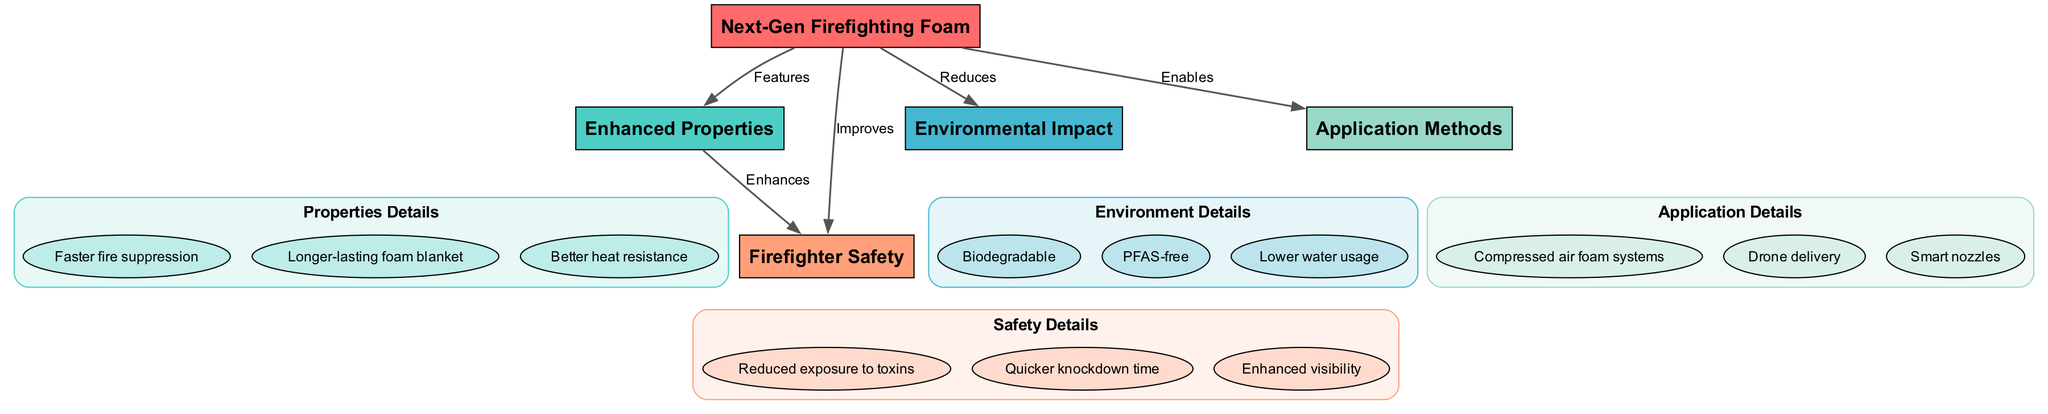What is the main subject of the diagram? The diagram is centered around "Next-Gen Firefighting Foam," which serves as the primary node that connects to various other topics surrounding its properties, environmental impact, safety, and application methods.
Answer: Next-Gen Firefighting Foam How many enhancements are listed under "Enhanced Properties"? The "Enhanced Properties" sub-node includes three enhancements: Faster fire suppression, Longer-lasting foam blanket, and Better heat resistance, indicating there are three enhancements.
Answer: 3 What impact does the next-gen foam have on environmental factors? The diagram indicates that the next-gen foam "Reduces" environmental impact, and specifically lists features such as being Biodegradable, PFAS-free, and Lower water usage, highlighting a focus on environmental benefits.
Answer: Reduces What relationship exists between "Enhanced Properties" and "Firefighter Safety"? According to the diagram, "Enhanced Properties" leads to "Firefighter Safety" where it shows that the enhancements "Enhances" safety, implying a positive influence of foam properties on safety measures for firefighters.
Answer: Enhances Which application method allows the next-gen foam to be delivered remotely? The diagram lists "Drone delivery" as one of the application methods under "Application Methods," indicating a modern technique for remote delivery of the firefighting foam.
Answer: Drone delivery How does next-gen foam improve firefighter safety? The diagram states that the firefighting foam "Improves" firefighter safety and specifies three aspects: Reduced exposure to toxins, Quicker knockdown time, and Enhanced visibility, showing how it safeguards firefighters.
Answer: Improves What are the three topics connected to the "Next-Gen Firefighting Foam"? The four primary topics branched from "Next-Gen Firefighting Foam" are "Enhanced Properties," "Environmental Impact," "Firefighter Safety," and "Application Methods," revealing the multifaceted benefits of the foam.
Answer: 4 Which enhancement focuses on the duration of effectiveness? The sub-node "Longer-lasting foam blanket" under "Enhanced Properties" specifically addresses the duration of effectiveness, indicating a feature that ensures longer operational capacity during firefighting.
Answer: Longer-lasting foam blanket What do the safety enhancements seek to mitigate? The enhancements under "Firefighter Safety" primarily seek to mitigate the exposure to toxins and provide a quicker operational response through better visibility, promoting overall safety during firefighting operations.
Answer: Toxins 